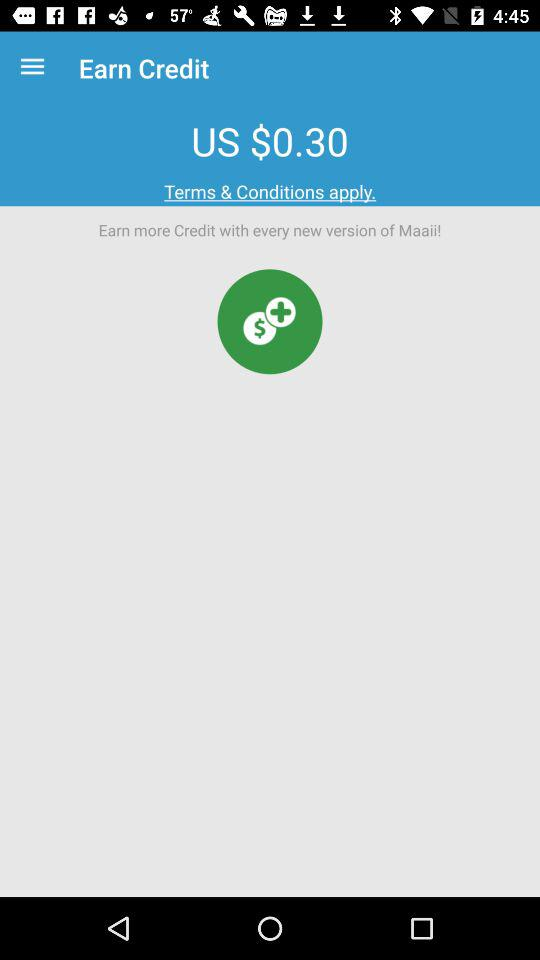What is the currency of price? The currency of price is dollars. 